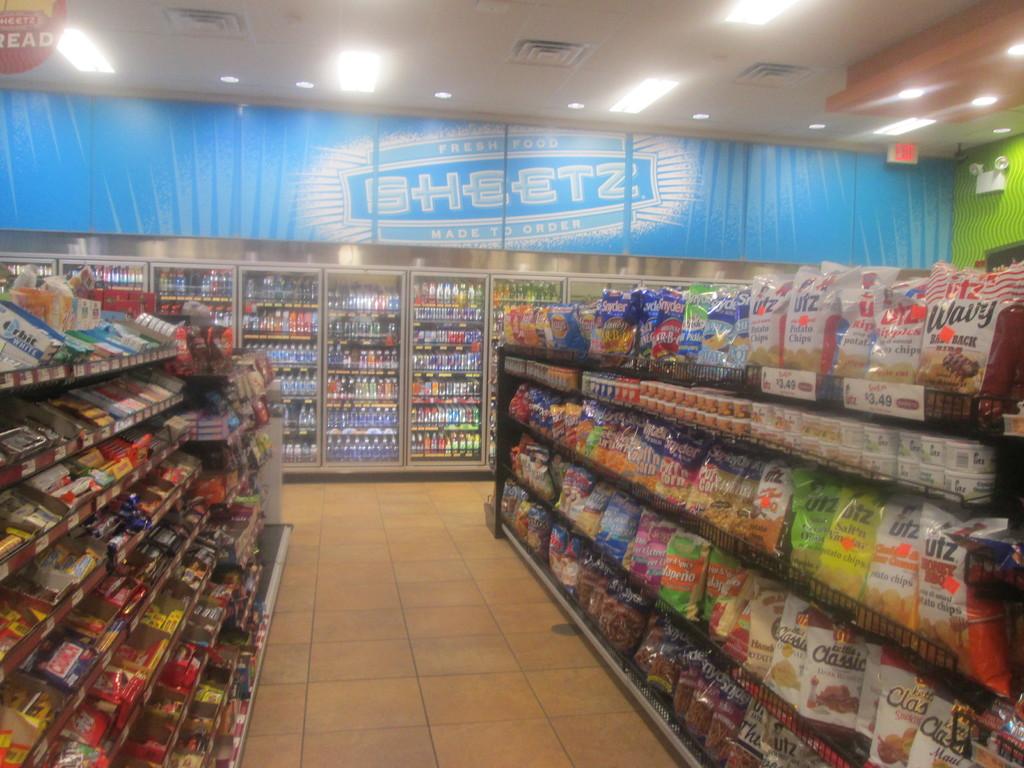What is the name of the company who supplies the food?
Your answer should be very brief. Sheetz. 